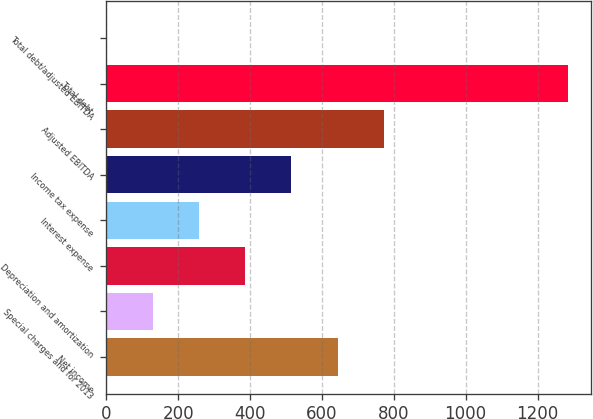Convert chart. <chart><loc_0><loc_0><loc_500><loc_500><bar_chart><fcel>Net income<fcel>Special charges and for 2013<fcel>Depreciation and amortization<fcel>Interest expense<fcel>Income tax expense<fcel>Adjusted EBITDA<fcel>Total debt<fcel>Total debt/adjusted EBITDA<nl><fcel>643.33<fcel>130.05<fcel>386.69<fcel>258.37<fcel>515.01<fcel>771.65<fcel>1284.9<fcel>1.73<nl></chart> 